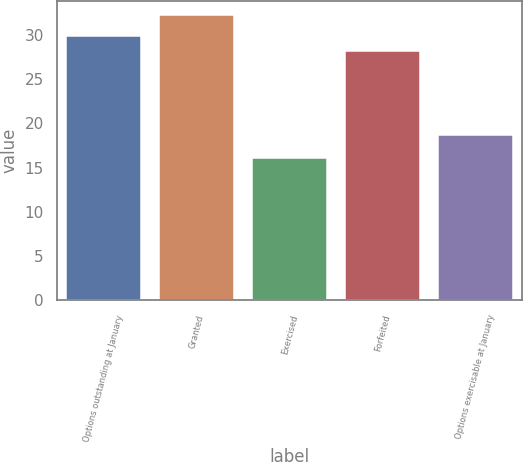Convert chart. <chart><loc_0><loc_0><loc_500><loc_500><bar_chart><fcel>Options outstanding at January<fcel>Granted<fcel>Exercised<fcel>Forfeited<fcel>Options exercisable at January<nl><fcel>29.82<fcel>32.25<fcel>16.12<fcel>28.21<fcel>18.73<nl></chart> 